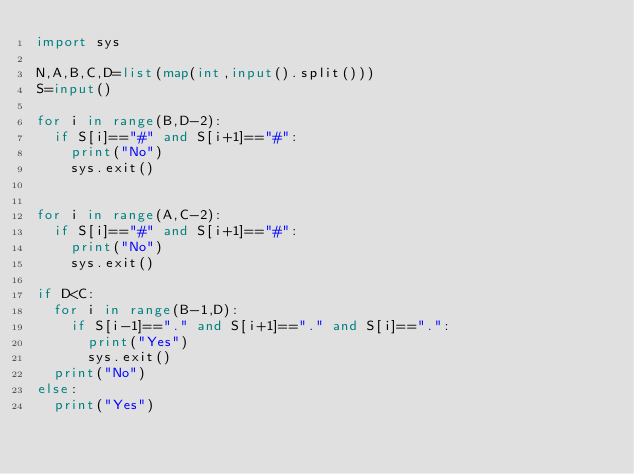Convert code to text. <code><loc_0><loc_0><loc_500><loc_500><_Python_>import sys

N,A,B,C,D=list(map(int,input().split()))
S=input()

for i in range(B,D-2):
	if S[i]=="#" and S[i+1]=="#":
		print("No")
		sys.exit()


for i in range(A,C-2):
	if S[i]=="#" and S[i+1]=="#":
		print("No")
		sys.exit()

if D<C:
	for i in range(B-1,D):
		if S[i-1]=="." and S[i+1]=="." and S[i]==".":
			print("Yes")
			sys.exit()
	print("No")
else:
	print("Yes")</code> 